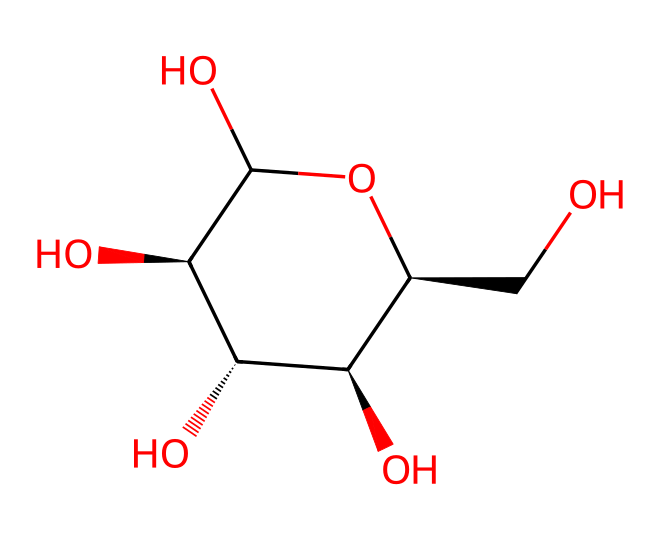What is the molecular formula of this compound? To determine the molecular formula, count the number of each type of atom present in the SMILES representation. From examining the structure, there are 6 carbon atoms (C), 12 hydrogen atoms (H), and 6 oxygen atoms (O). Therefore, the molecular formula is C6H12O6.
Answer: C6H12O6 How many chiral centers are present in this compound? A chiral center typically has four different substituents attached to it. In the structure provided, there are four carbon atoms that have four different substituents around them. Therefore, there are four chiral centers in glucose.
Answer: 4 What type of stereoisomerism does this compound exhibit? This compound exhibits configurational isomerism because it contains chiral centers. Stereoisomers differ in the spatial arrangement of their atoms, specifically around the chiral centers.
Answer: configurational isomerism Why is the stereochemistry of glucose important for its function in biology? The stereochemistry is crucial because enzymes are specific to the shape of molecules. The different spatial arrangements of the atoms lead to different properties and reactivities. Thus, only one stereoisomer of glucose can be utilized efficiently by biological systems, highlighting the importance of stereochemistry.
Answer: specificity of enzymes What is the anomeric carbon in this compound? The anomeric carbon is the carbon that was the carbonyl carbon in the open-chain form of glucose. In the cyclic form, it becomes a chiral center located at the first carbon (C1).
Answer: C1 How does the chiral nature of glucose affect its sweetness perception? Chiral compounds can interact differently with taste receptors. The specific arrangement of groups in glucose allows it to activate the sweetness receptors in our taste buds, leading to the perception of sweetness. Other sugars with different chiral arrangements may taste differently.
Answer: affects sweetness perception 